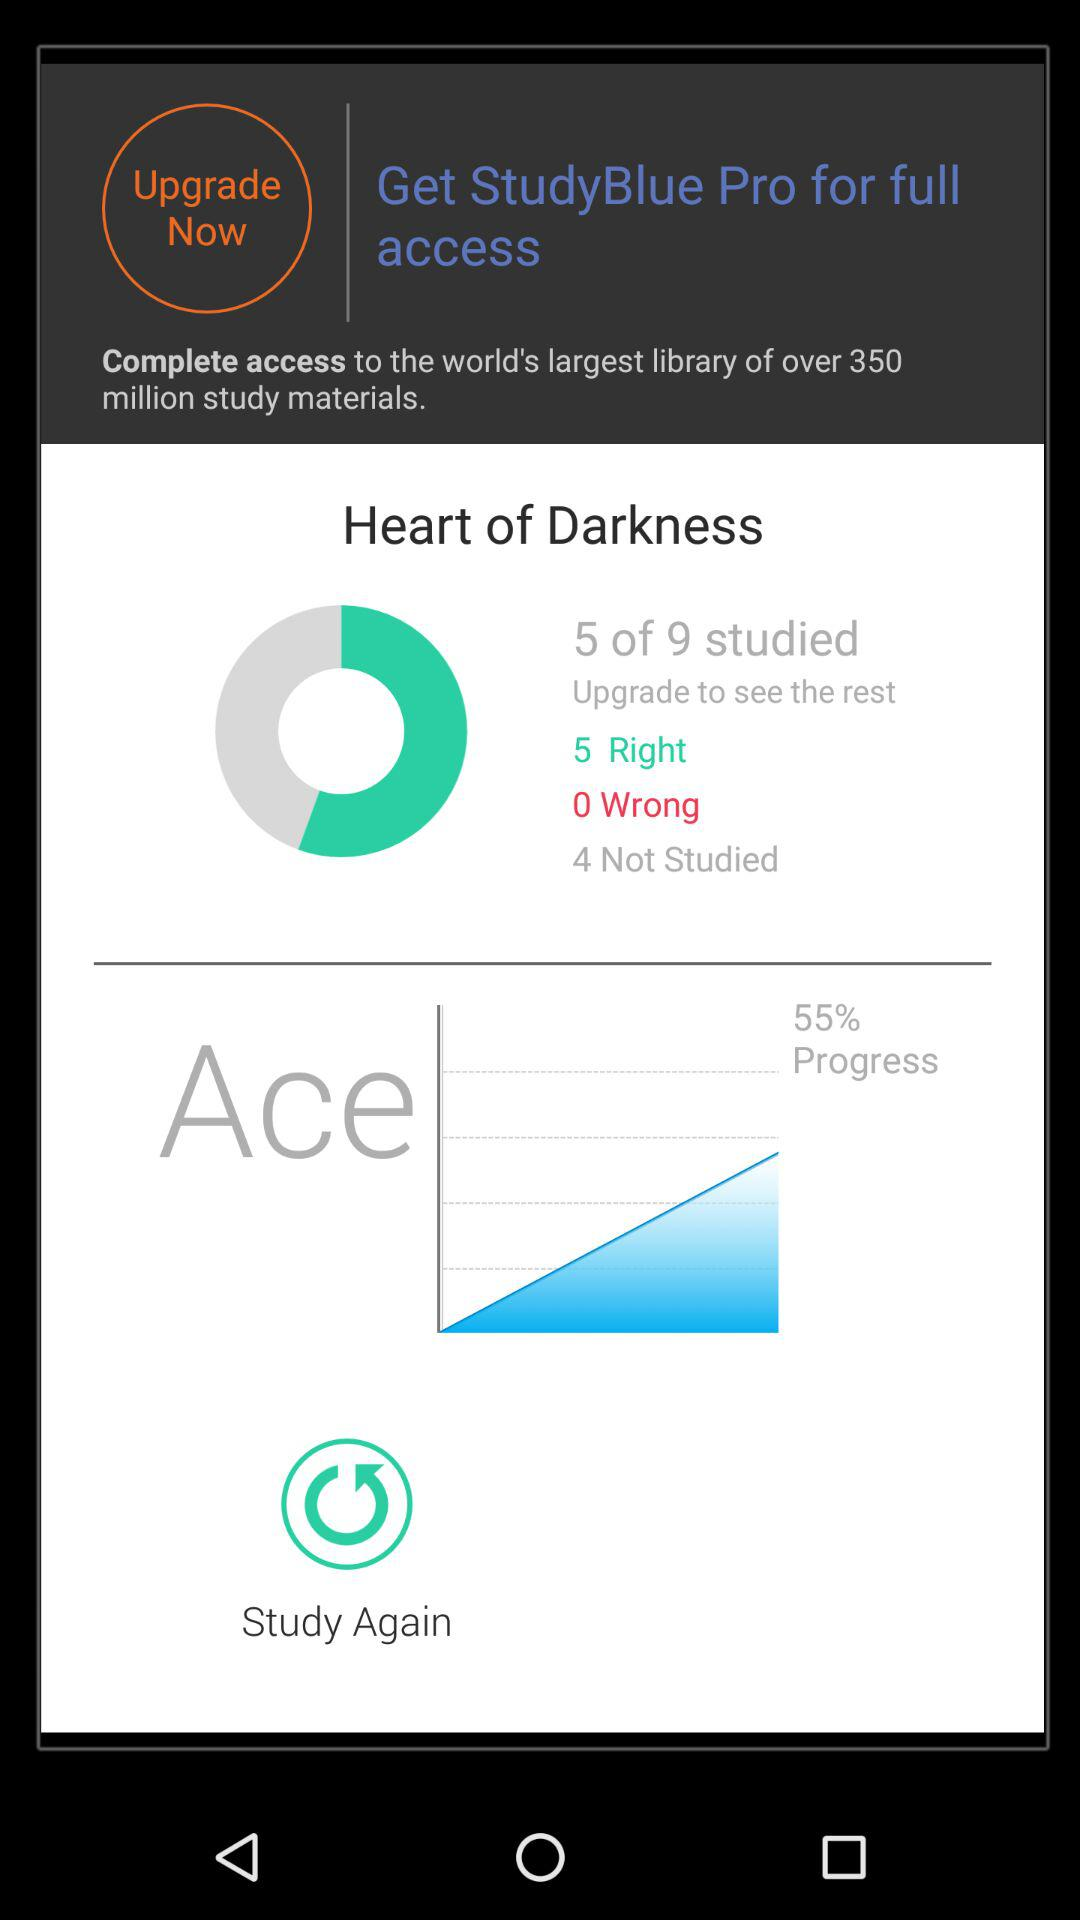What is the total number of "Wrong"? The total number of "Wrong" is zero. 